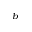<formula> <loc_0><loc_0><loc_500><loc_500>^ { b }</formula> 